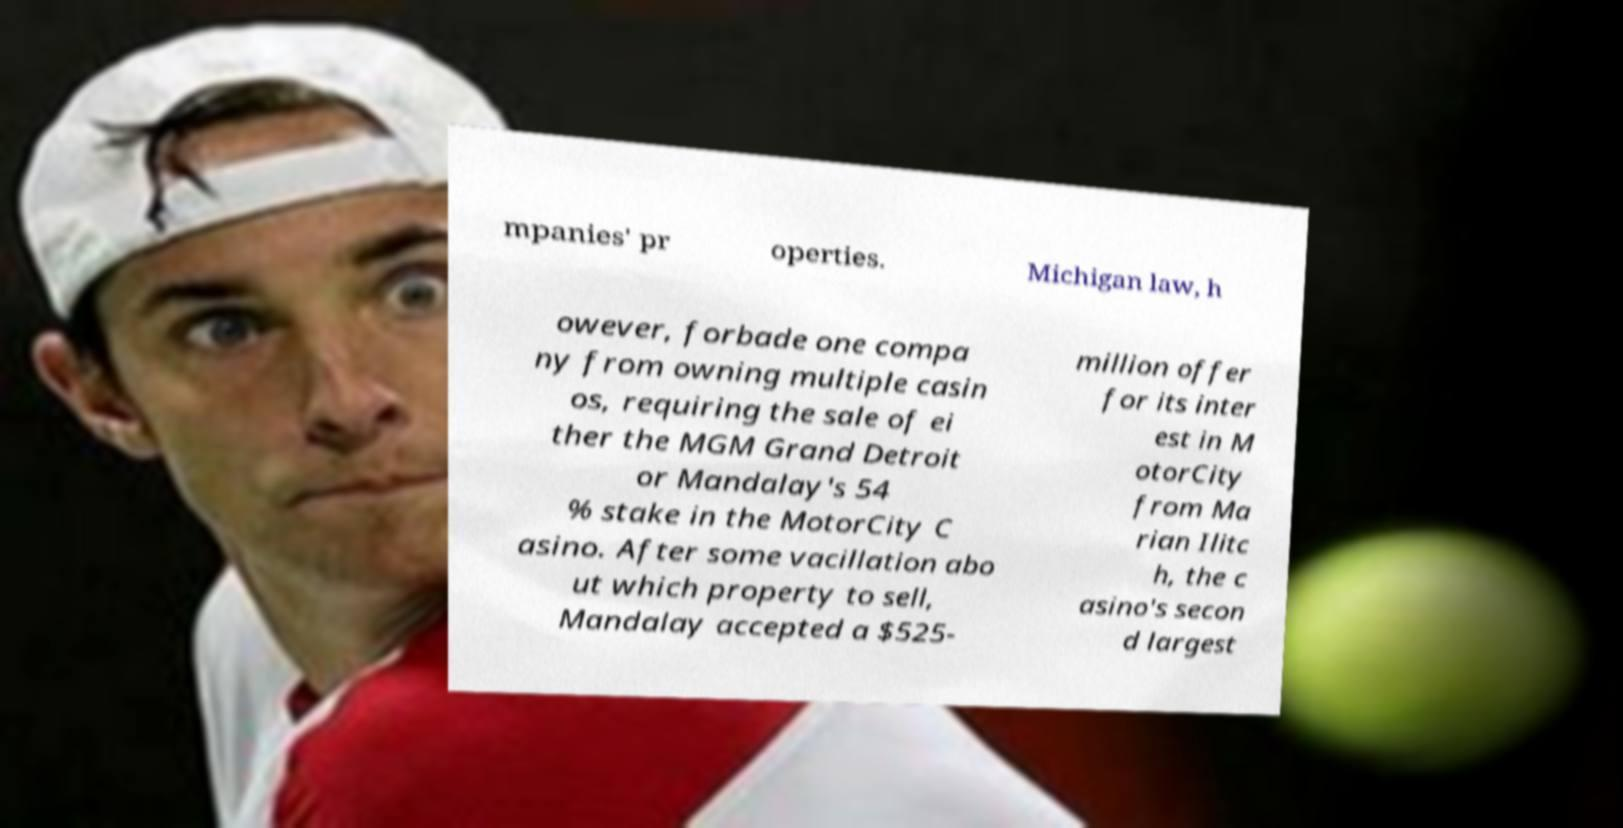For documentation purposes, I need the text within this image transcribed. Could you provide that? mpanies' pr operties. Michigan law, h owever, forbade one compa ny from owning multiple casin os, requiring the sale of ei ther the MGM Grand Detroit or Mandalay's 54 % stake in the MotorCity C asino. After some vacillation abo ut which property to sell, Mandalay accepted a $525- million offer for its inter est in M otorCity from Ma rian Ilitc h, the c asino's secon d largest 